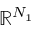<formula> <loc_0><loc_0><loc_500><loc_500>\mathbb { R } ^ { N _ { 1 } }</formula> 